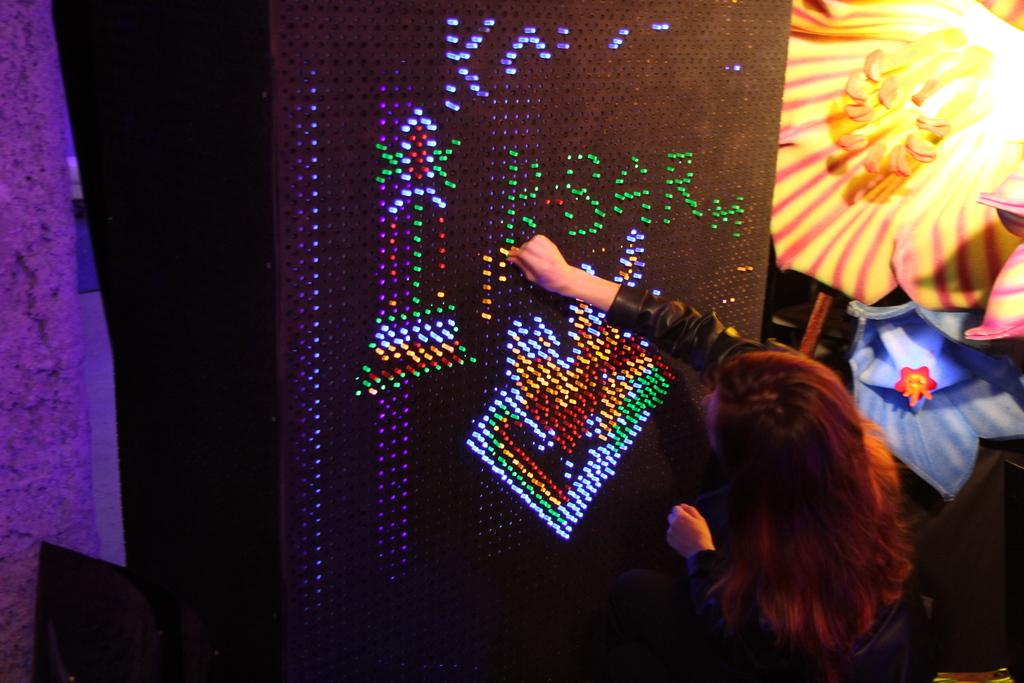What is the main object in the image? There is a board in the image. Are there any additional features near the board? Yes, there are lights near the board. Can you describe the people in the image? There is a woman in the image. What decorative element can be seen in the top right corner of the image? There is a flower in the top right corner of the image. What is the purpose of the cloth on the left side of the image? The cloth on the left side of the image is not clearly visible or described in the provided facts. Can you tell me how many kittens are sleeping on the board in the image? There are no kittens present in the image, and therefore no such activity can be observed. 